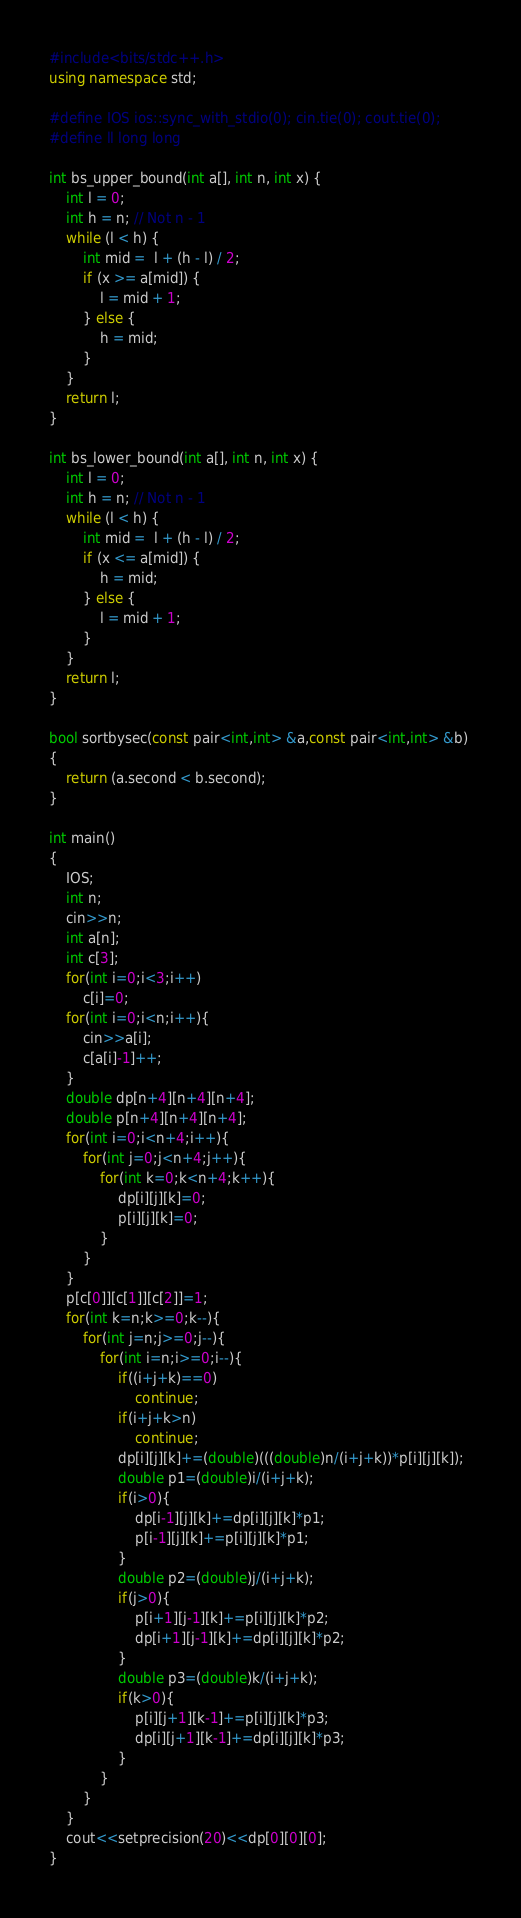<code> <loc_0><loc_0><loc_500><loc_500><_C++_>#include<bits/stdc++.h>
using namespace std;

#define IOS ios::sync_with_stdio(0); cin.tie(0); cout.tie(0);
#define ll long long

int bs_upper_bound(int a[], int n, int x) {
    int l = 0;
    int h = n; // Not n - 1
    while (l < h) {
        int mid =  l + (h - l) / 2;
        if (x >= a[mid]) {
            l = mid + 1;
        } else {
            h = mid;
        }
    }
    return l;
}

int bs_lower_bound(int a[], int n, int x) {
    int l = 0;
    int h = n; // Not n - 1
    while (l < h) {
        int mid =  l + (h - l) / 2;
        if (x <= a[mid]) {
            h = mid;
        } else {
            l = mid + 1;
        }
    }
    return l;
}

bool sortbysec(const pair<int,int> &a,const pair<int,int> &b) 
{ 
    return (a.second < b.second); 
} 

int main()
{
    IOS;
    int n;
    cin>>n;
    int a[n];
    int c[3];
    for(int i=0;i<3;i++)
        c[i]=0;
    for(int i=0;i<n;i++){
        cin>>a[i];
        c[a[i]-1]++;
    }
    double dp[n+4][n+4][n+4];
    double p[n+4][n+4][n+4];
    for(int i=0;i<n+4;i++){
        for(int j=0;j<n+4;j++){
            for(int k=0;k<n+4;k++){
                dp[i][j][k]=0;
                p[i][j][k]=0;
            }
        }
    }
    p[c[0]][c[1]][c[2]]=1;
    for(int k=n;k>=0;k--){
        for(int j=n;j>=0;j--){
            for(int i=n;i>=0;i--){
                if((i+j+k)==0)
                    continue;
                if(i+j+k>n)
                    continue;
                dp[i][j][k]+=(double)(((double)n/(i+j+k))*p[i][j][k]);
                double p1=(double)i/(i+j+k);
                if(i>0){
                    dp[i-1][j][k]+=dp[i][j][k]*p1;
                    p[i-1][j][k]+=p[i][j][k]*p1;
                }
                double p2=(double)j/(i+j+k);
                if(j>0){
                    p[i+1][j-1][k]+=p[i][j][k]*p2;
                    dp[i+1][j-1][k]+=dp[i][j][k]*p2;
                }
                double p3=(double)k/(i+j+k);
                if(k>0){
                    p[i][j+1][k-1]+=p[i][j][k]*p3;
                    dp[i][j+1][k-1]+=dp[i][j][k]*p3;
                }
            }
        }
    }
    cout<<setprecision(20)<<dp[0][0][0];
}
</code> 